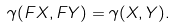<formula> <loc_0><loc_0><loc_500><loc_500>\gamma ( F X , F Y ) = \gamma ( X , Y ) .</formula> 